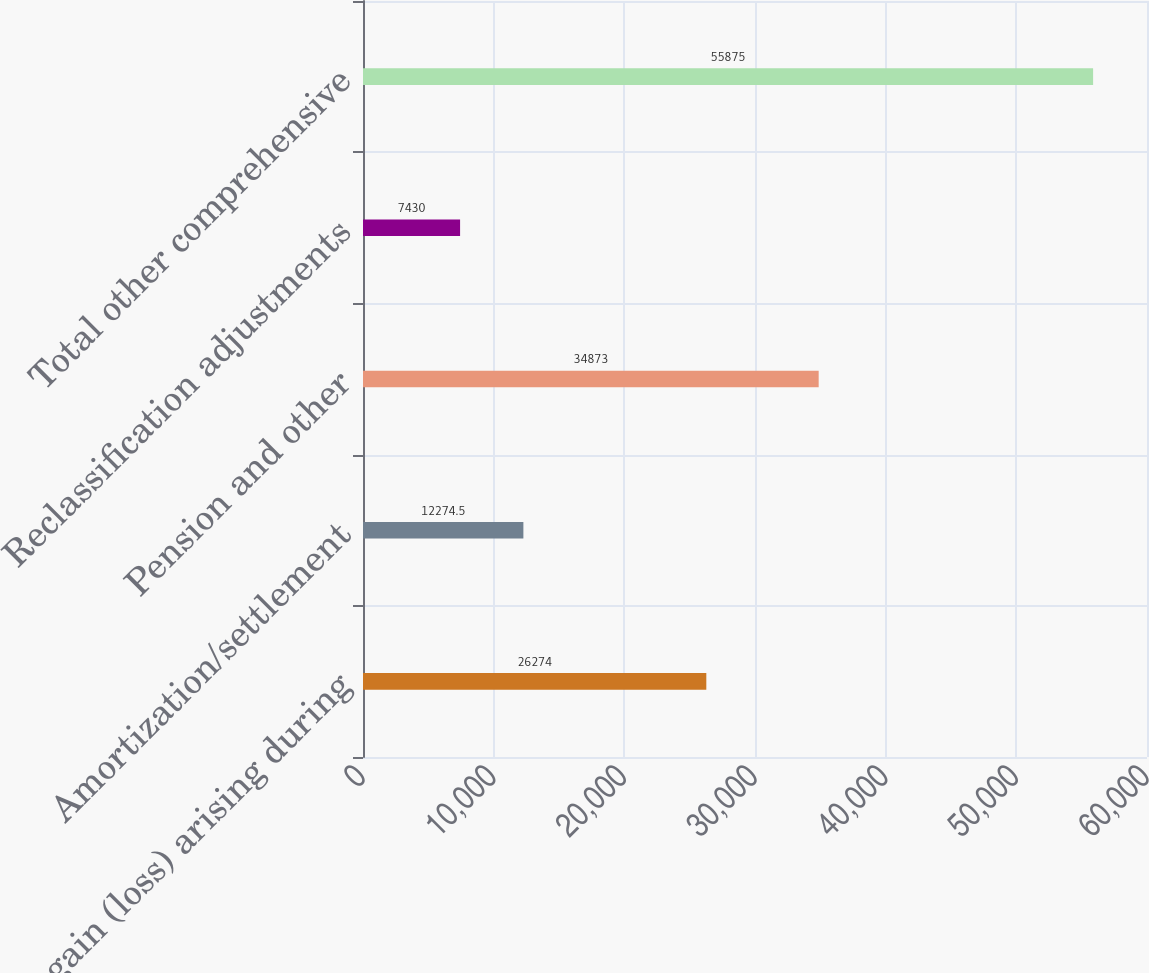Convert chart. <chart><loc_0><loc_0><loc_500><loc_500><bar_chart><fcel>Net gain (loss) arising during<fcel>Amortization/settlement<fcel>Pension and other<fcel>Reclassification adjustments<fcel>Total other comprehensive<nl><fcel>26274<fcel>12274.5<fcel>34873<fcel>7430<fcel>55875<nl></chart> 